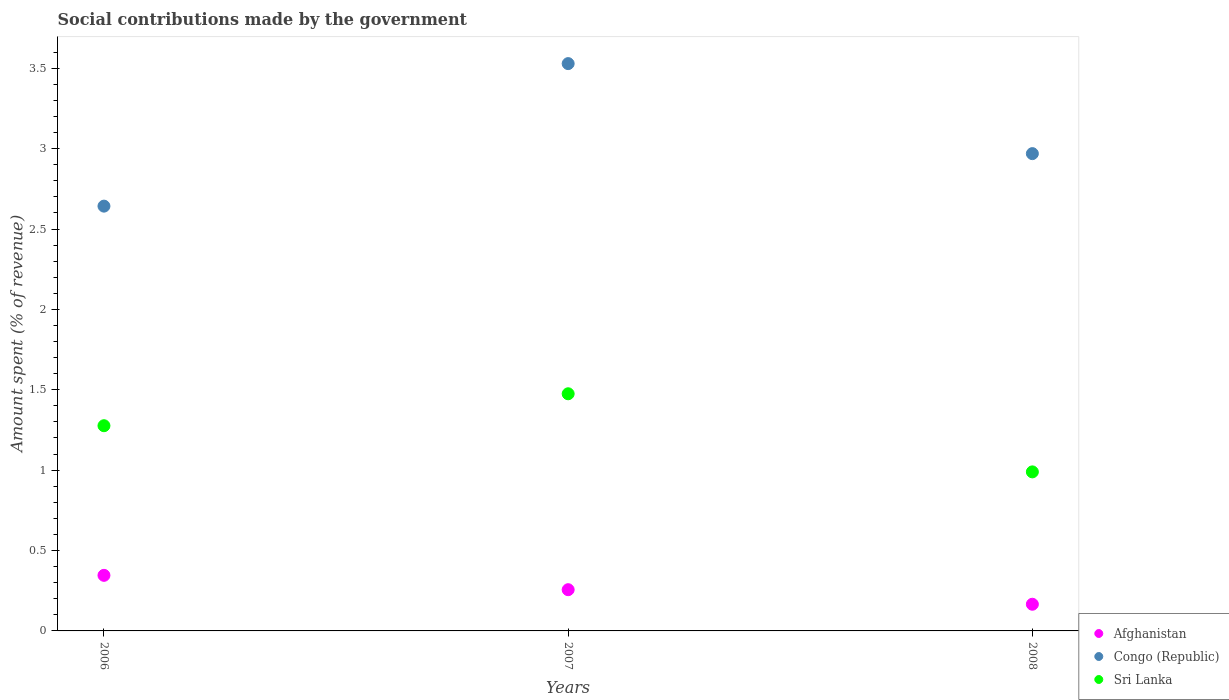How many different coloured dotlines are there?
Give a very brief answer. 3. Is the number of dotlines equal to the number of legend labels?
Offer a very short reply. Yes. What is the amount spent (in %) on social contributions in Congo (Republic) in 2008?
Provide a short and direct response. 2.97. Across all years, what is the maximum amount spent (in %) on social contributions in Sri Lanka?
Your answer should be compact. 1.48. Across all years, what is the minimum amount spent (in %) on social contributions in Afghanistan?
Make the answer very short. 0.17. In which year was the amount spent (in %) on social contributions in Afghanistan minimum?
Your answer should be compact. 2008. What is the total amount spent (in %) on social contributions in Sri Lanka in the graph?
Provide a succinct answer. 3.74. What is the difference between the amount spent (in %) on social contributions in Afghanistan in 2006 and that in 2007?
Your answer should be compact. 0.09. What is the difference between the amount spent (in %) on social contributions in Congo (Republic) in 2006 and the amount spent (in %) on social contributions in Sri Lanka in 2007?
Provide a short and direct response. 1.17. What is the average amount spent (in %) on social contributions in Congo (Republic) per year?
Offer a very short reply. 3.05. In the year 2008, what is the difference between the amount spent (in %) on social contributions in Sri Lanka and amount spent (in %) on social contributions in Afghanistan?
Keep it short and to the point. 0.82. In how many years, is the amount spent (in %) on social contributions in Sri Lanka greater than 3.3 %?
Give a very brief answer. 0. What is the ratio of the amount spent (in %) on social contributions in Sri Lanka in 2006 to that in 2008?
Keep it short and to the point. 1.29. Is the difference between the amount spent (in %) on social contributions in Sri Lanka in 2006 and 2007 greater than the difference between the amount spent (in %) on social contributions in Afghanistan in 2006 and 2007?
Keep it short and to the point. No. What is the difference between the highest and the second highest amount spent (in %) on social contributions in Sri Lanka?
Provide a succinct answer. 0.2. What is the difference between the highest and the lowest amount spent (in %) on social contributions in Congo (Republic)?
Your answer should be very brief. 0.89. In how many years, is the amount spent (in %) on social contributions in Congo (Republic) greater than the average amount spent (in %) on social contributions in Congo (Republic) taken over all years?
Keep it short and to the point. 1. Is the sum of the amount spent (in %) on social contributions in Afghanistan in 2006 and 2007 greater than the maximum amount spent (in %) on social contributions in Sri Lanka across all years?
Provide a short and direct response. No. Does the amount spent (in %) on social contributions in Afghanistan monotonically increase over the years?
Your response must be concise. No. Is the amount spent (in %) on social contributions in Congo (Republic) strictly less than the amount spent (in %) on social contributions in Afghanistan over the years?
Offer a very short reply. No. How many years are there in the graph?
Offer a terse response. 3. What is the difference between two consecutive major ticks on the Y-axis?
Provide a succinct answer. 0.5. Where does the legend appear in the graph?
Give a very brief answer. Bottom right. What is the title of the graph?
Provide a succinct answer. Social contributions made by the government. Does "Uruguay" appear as one of the legend labels in the graph?
Give a very brief answer. No. What is the label or title of the Y-axis?
Ensure brevity in your answer.  Amount spent (% of revenue). What is the Amount spent (% of revenue) of Afghanistan in 2006?
Make the answer very short. 0.35. What is the Amount spent (% of revenue) in Congo (Republic) in 2006?
Offer a terse response. 2.64. What is the Amount spent (% of revenue) of Sri Lanka in 2006?
Offer a very short reply. 1.28. What is the Amount spent (% of revenue) in Afghanistan in 2007?
Your answer should be very brief. 0.26. What is the Amount spent (% of revenue) of Congo (Republic) in 2007?
Your answer should be very brief. 3.53. What is the Amount spent (% of revenue) of Sri Lanka in 2007?
Your response must be concise. 1.48. What is the Amount spent (% of revenue) in Afghanistan in 2008?
Provide a succinct answer. 0.17. What is the Amount spent (% of revenue) in Congo (Republic) in 2008?
Offer a terse response. 2.97. What is the Amount spent (% of revenue) of Sri Lanka in 2008?
Your response must be concise. 0.99. Across all years, what is the maximum Amount spent (% of revenue) of Afghanistan?
Provide a short and direct response. 0.35. Across all years, what is the maximum Amount spent (% of revenue) in Congo (Republic)?
Make the answer very short. 3.53. Across all years, what is the maximum Amount spent (% of revenue) in Sri Lanka?
Provide a succinct answer. 1.48. Across all years, what is the minimum Amount spent (% of revenue) of Afghanistan?
Your answer should be very brief. 0.17. Across all years, what is the minimum Amount spent (% of revenue) in Congo (Republic)?
Offer a terse response. 2.64. Across all years, what is the minimum Amount spent (% of revenue) of Sri Lanka?
Provide a succinct answer. 0.99. What is the total Amount spent (% of revenue) of Afghanistan in the graph?
Provide a succinct answer. 0.77. What is the total Amount spent (% of revenue) in Congo (Republic) in the graph?
Make the answer very short. 9.14. What is the total Amount spent (% of revenue) in Sri Lanka in the graph?
Offer a very short reply. 3.74. What is the difference between the Amount spent (% of revenue) of Afghanistan in 2006 and that in 2007?
Provide a succinct answer. 0.09. What is the difference between the Amount spent (% of revenue) of Congo (Republic) in 2006 and that in 2007?
Give a very brief answer. -0.89. What is the difference between the Amount spent (% of revenue) of Sri Lanka in 2006 and that in 2007?
Offer a very short reply. -0.2. What is the difference between the Amount spent (% of revenue) in Afghanistan in 2006 and that in 2008?
Give a very brief answer. 0.18. What is the difference between the Amount spent (% of revenue) of Congo (Republic) in 2006 and that in 2008?
Your answer should be compact. -0.33. What is the difference between the Amount spent (% of revenue) in Sri Lanka in 2006 and that in 2008?
Ensure brevity in your answer.  0.29. What is the difference between the Amount spent (% of revenue) of Afghanistan in 2007 and that in 2008?
Make the answer very short. 0.09. What is the difference between the Amount spent (% of revenue) of Congo (Republic) in 2007 and that in 2008?
Make the answer very short. 0.56. What is the difference between the Amount spent (% of revenue) of Sri Lanka in 2007 and that in 2008?
Provide a short and direct response. 0.49. What is the difference between the Amount spent (% of revenue) of Afghanistan in 2006 and the Amount spent (% of revenue) of Congo (Republic) in 2007?
Make the answer very short. -3.18. What is the difference between the Amount spent (% of revenue) of Afghanistan in 2006 and the Amount spent (% of revenue) of Sri Lanka in 2007?
Provide a short and direct response. -1.13. What is the difference between the Amount spent (% of revenue) in Congo (Republic) in 2006 and the Amount spent (% of revenue) in Sri Lanka in 2007?
Your answer should be compact. 1.17. What is the difference between the Amount spent (% of revenue) of Afghanistan in 2006 and the Amount spent (% of revenue) of Congo (Republic) in 2008?
Ensure brevity in your answer.  -2.62. What is the difference between the Amount spent (% of revenue) in Afghanistan in 2006 and the Amount spent (% of revenue) in Sri Lanka in 2008?
Provide a short and direct response. -0.64. What is the difference between the Amount spent (% of revenue) of Congo (Republic) in 2006 and the Amount spent (% of revenue) of Sri Lanka in 2008?
Keep it short and to the point. 1.65. What is the difference between the Amount spent (% of revenue) of Afghanistan in 2007 and the Amount spent (% of revenue) of Congo (Republic) in 2008?
Your response must be concise. -2.71. What is the difference between the Amount spent (% of revenue) of Afghanistan in 2007 and the Amount spent (% of revenue) of Sri Lanka in 2008?
Offer a terse response. -0.73. What is the difference between the Amount spent (% of revenue) of Congo (Republic) in 2007 and the Amount spent (% of revenue) of Sri Lanka in 2008?
Your answer should be compact. 2.54. What is the average Amount spent (% of revenue) of Afghanistan per year?
Provide a short and direct response. 0.26. What is the average Amount spent (% of revenue) of Congo (Republic) per year?
Ensure brevity in your answer.  3.05. What is the average Amount spent (% of revenue) of Sri Lanka per year?
Your answer should be compact. 1.25. In the year 2006, what is the difference between the Amount spent (% of revenue) in Afghanistan and Amount spent (% of revenue) in Congo (Republic)?
Offer a very short reply. -2.3. In the year 2006, what is the difference between the Amount spent (% of revenue) of Afghanistan and Amount spent (% of revenue) of Sri Lanka?
Your response must be concise. -0.93. In the year 2006, what is the difference between the Amount spent (% of revenue) in Congo (Republic) and Amount spent (% of revenue) in Sri Lanka?
Provide a short and direct response. 1.37. In the year 2007, what is the difference between the Amount spent (% of revenue) of Afghanistan and Amount spent (% of revenue) of Congo (Republic)?
Offer a terse response. -3.27. In the year 2007, what is the difference between the Amount spent (% of revenue) in Afghanistan and Amount spent (% of revenue) in Sri Lanka?
Provide a succinct answer. -1.22. In the year 2007, what is the difference between the Amount spent (% of revenue) of Congo (Republic) and Amount spent (% of revenue) of Sri Lanka?
Offer a very short reply. 2.05. In the year 2008, what is the difference between the Amount spent (% of revenue) of Afghanistan and Amount spent (% of revenue) of Congo (Republic)?
Give a very brief answer. -2.8. In the year 2008, what is the difference between the Amount spent (% of revenue) in Afghanistan and Amount spent (% of revenue) in Sri Lanka?
Your answer should be compact. -0.82. In the year 2008, what is the difference between the Amount spent (% of revenue) in Congo (Republic) and Amount spent (% of revenue) in Sri Lanka?
Your response must be concise. 1.98. What is the ratio of the Amount spent (% of revenue) of Afghanistan in 2006 to that in 2007?
Make the answer very short. 1.35. What is the ratio of the Amount spent (% of revenue) in Congo (Republic) in 2006 to that in 2007?
Offer a very short reply. 0.75. What is the ratio of the Amount spent (% of revenue) in Sri Lanka in 2006 to that in 2007?
Offer a terse response. 0.87. What is the ratio of the Amount spent (% of revenue) of Afghanistan in 2006 to that in 2008?
Your answer should be very brief. 2.08. What is the ratio of the Amount spent (% of revenue) in Congo (Republic) in 2006 to that in 2008?
Your response must be concise. 0.89. What is the ratio of the Amount spent (% of revenue) in Sri Lanka in 2006 to that in 2008?
Provide a succinct answer. 1.29. What is the ratio of the Amount spent (% of revenue) in Afghanistan in 2007 to that in 2008?
Give a very brief answer. 1.55. What is the ratio of the Amount spent (% of revenue) in Congo (Republic) in 2007 to that in 2008?
Provide a succinct answer. 1.19. What is the ratio of the Amount spent (% of revenue) in Sri Lanka in 2007 to that in 2008?
Offer a very short reply. 1.49. What is the difference between the highest and the second highest Amount spent (% of revenue) of Afghanistan?
Provide a succinct answer. 0.09. What is the difference between the highest and the second highest Amount spent (% of revenue) of Congo (Republic)?
Give a very brief answer. 0.56. What is the difference between the highest and the second highest Amount spent (% of revenue) in Sri Lanka?
Your answer should be very brief. 0.2. What is the difference between the highest and the lowest Amount spent (% of revenue) in Afghanistan?
Provide a short and direct response. 0.18. What is the difference between the highest and the lowest Amount spent (% of revenue) in Congo (Republic)?
Offer a very short reply. 0.89. What is the difference between the highest and the lowest Amount spent (% of revenue) in Sri Lanka?
Make the answer very short. 0.49. 